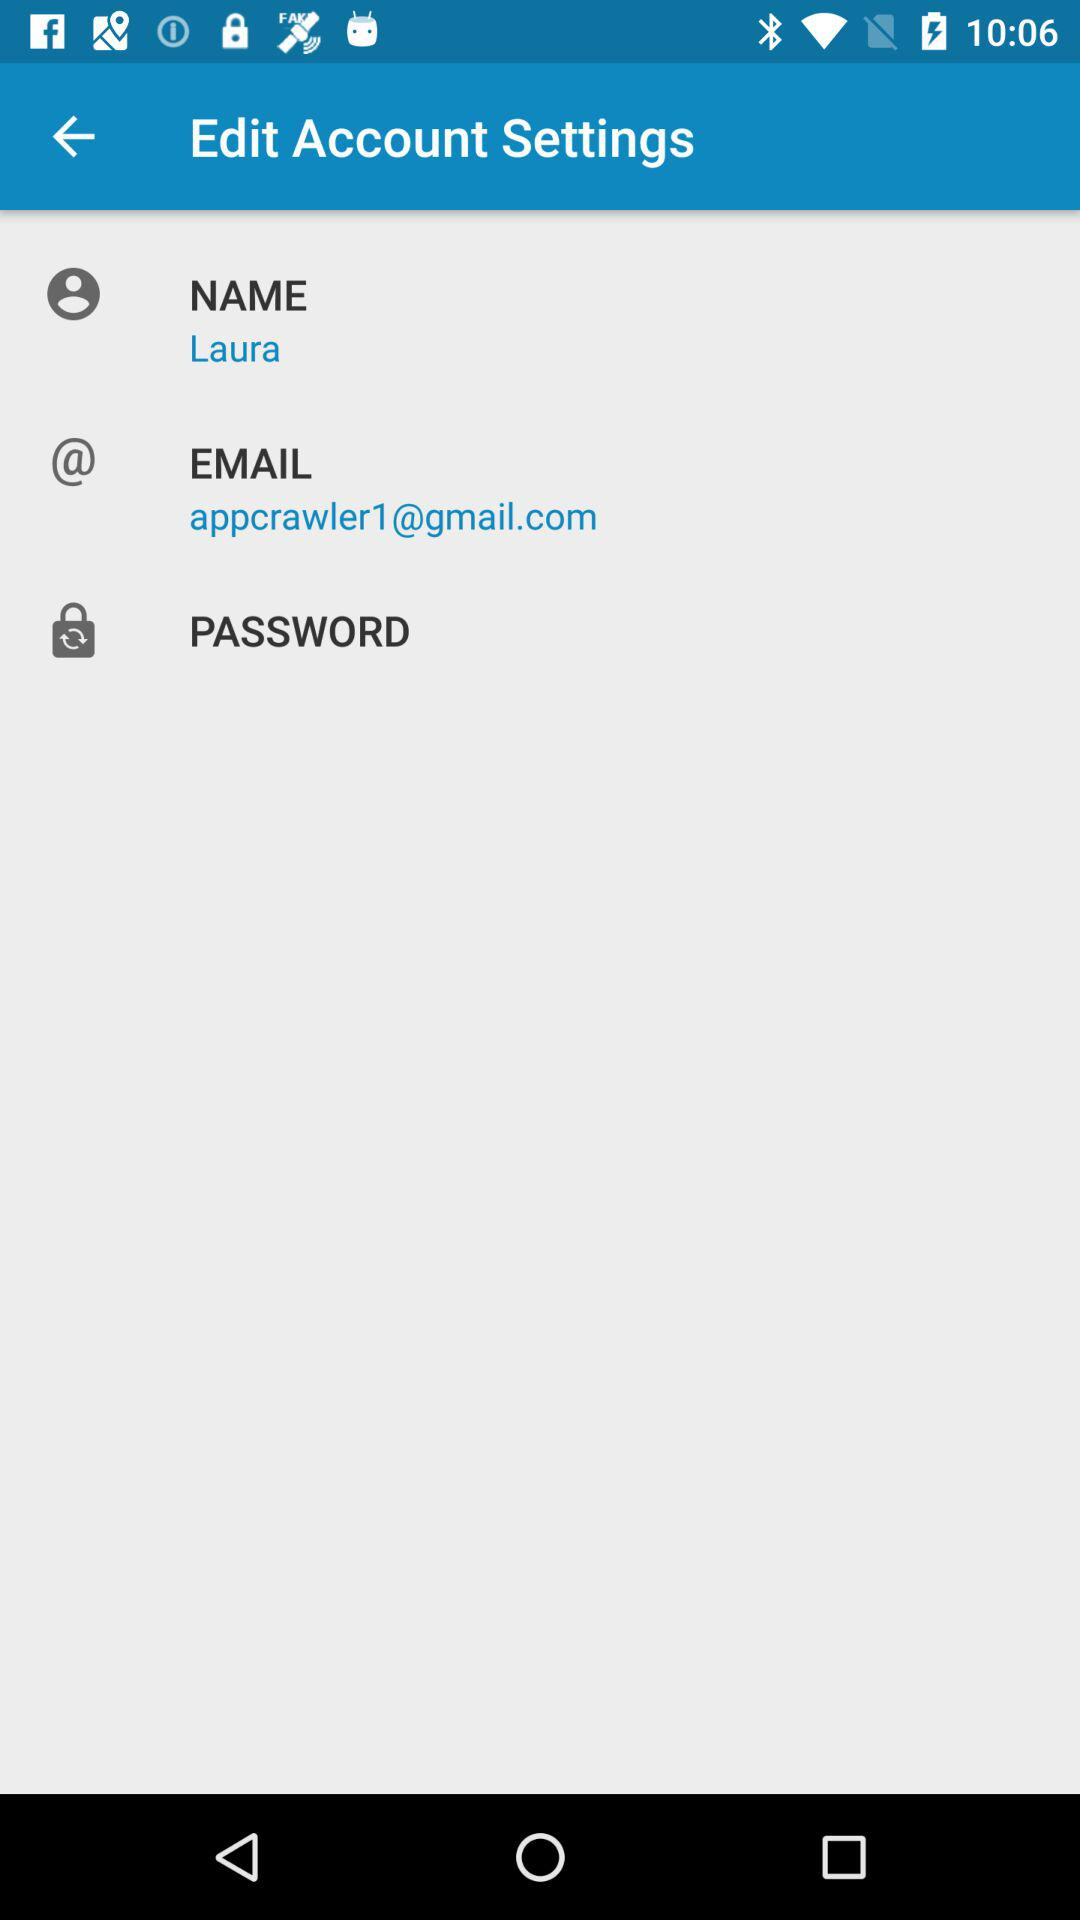What is the mentioned name? The mentioned name is Laura. 